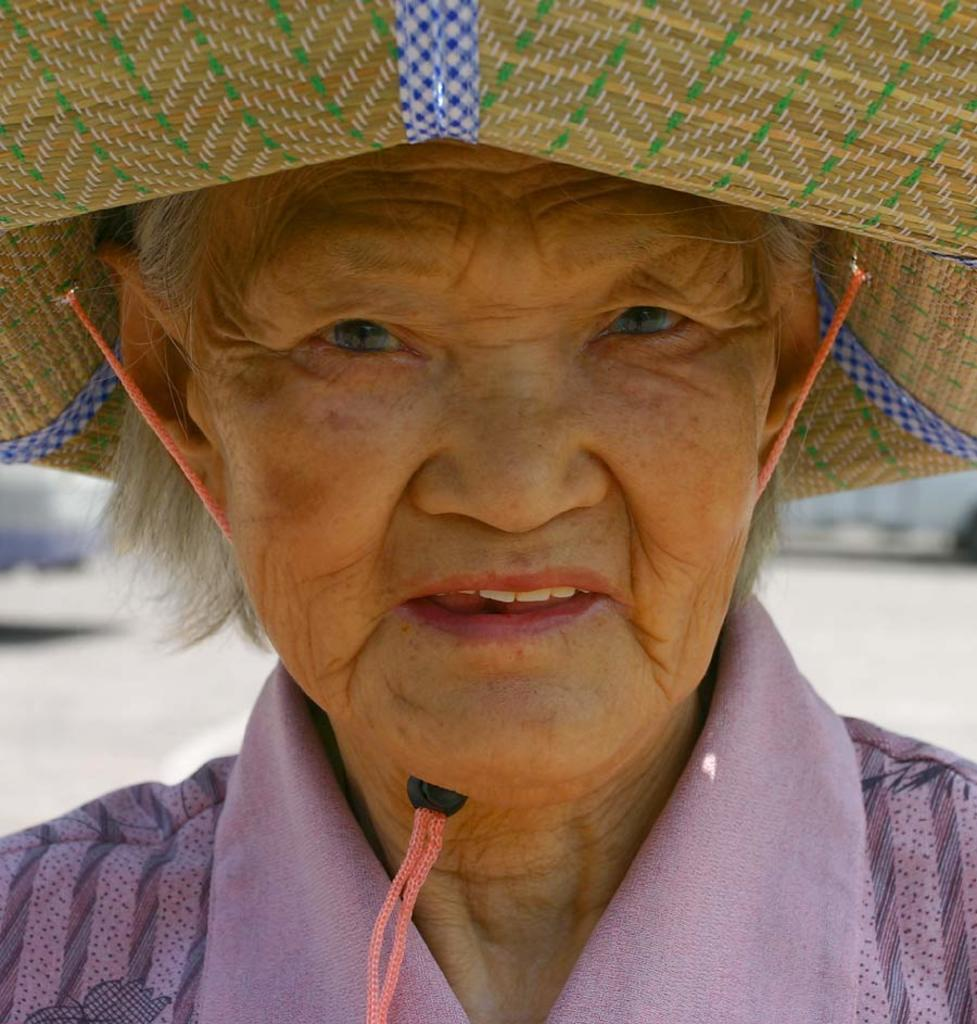What is the main subject of the image? The main subject of the image is an old woman's face. What is the woman wearing in the image? The woman is wearing a purple-colored dress and a hat. Can you describe the background of the image? The surface behind the woman is not clearly visible, so it is difficult to describe the background. What type of ship can be seen in the woman's yard in the image? There is no ship or yard present in the image; it features an old woman's face with a purple dress and a hat. What is the woman made of in the image? The woman is a real person, not made of wax, in the image. 